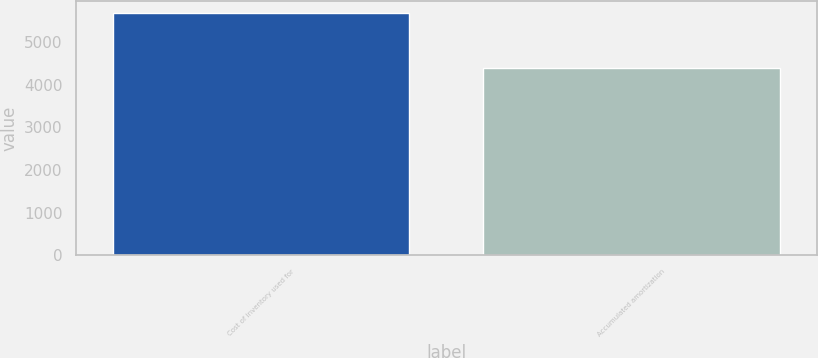<chart> <loc_0><loc_0><loc_500><loc_500><bar_chart><fcel>Cost of inventory used for<fcel>Accumulated amortization<nl><fcel>5680<fcel>4386<nl></chart> 